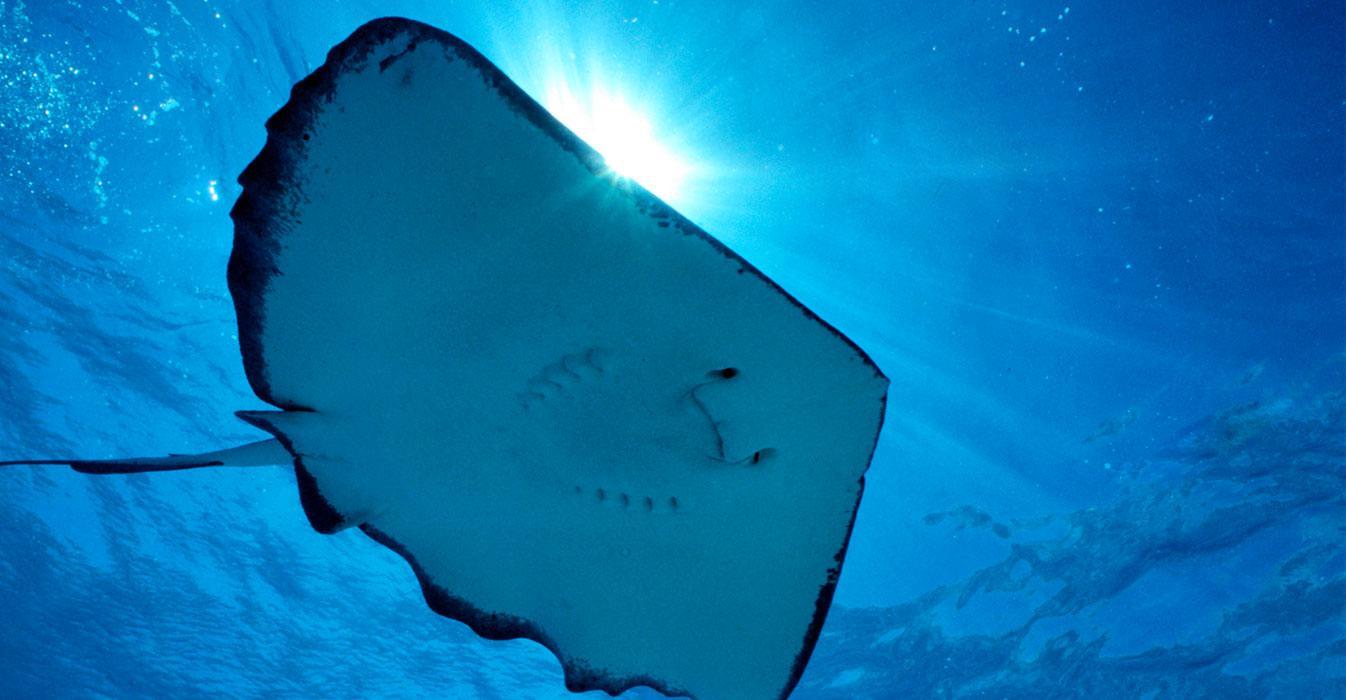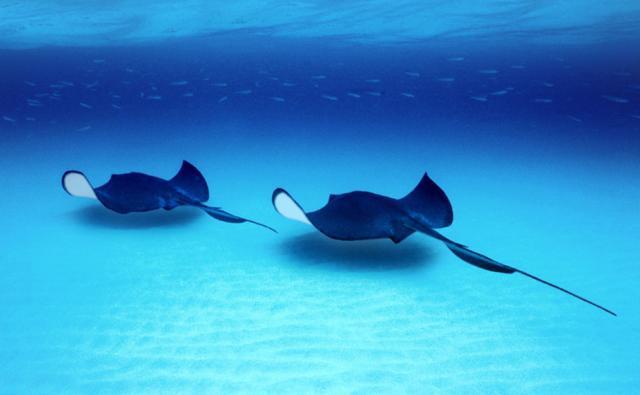The first image is the image on the left, the second image is the image on the right. Given the left and right images, does the statement "Two stingrays are swimming on the floor of the sea in the image on the right." hold true? Answer yes or no. Yes. 